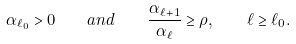<formula> <loc_0><loc_0><loc_500><loc_500>\alpha _ { \ell _ { 0 } } > 0 \quad a n d \quad \frac { \alpha _ { \ell + 1 } } { \alpha _ { \ell } } \geq \rho , \quad \ell \geq \ell _ { 0 } .</formula> 